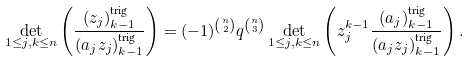Convert formula to latex. <formula><loc_0><loc_0><loc_500><loc_500>\det _ { 1 \leq j , k \leq n } \left ( \frac { ( z _ { j } ) _ { k - 1 } ^ { \text {trig} } } { ( a _ { j } z _ { j } ) _ { k - 1 } ^ { \text {trig} } } \right ) = ( - 1 ) ^ { \binom { n } { 2 } } q ^ { \binom { n } { 3 } } \det _ { 1 \leq j , k \leq n } \left ( z _ { j } ^ { k - 1 } \frac { ( a _ { j } ) _ { k - 1 } ^ { \text {trig} } } { ( a _ { j } z _ { j } ) _ { k - 1 } ^ { \text {trig} } } \right ) .</formula> 